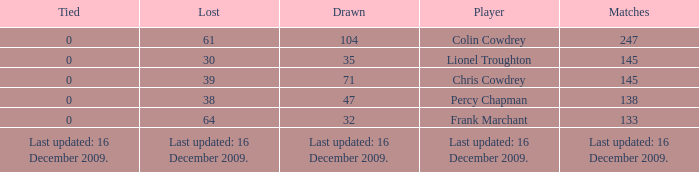I want to know the drawn that has a tie of 0 and the player is chris cowdrey 71.0. 